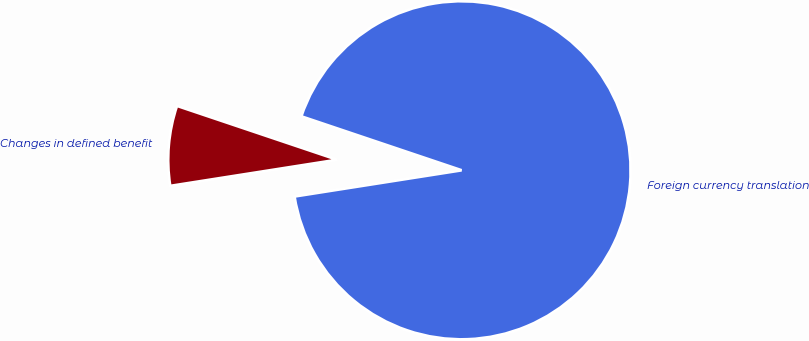Convert chart to OTSL. <chart><loc_0><loc_0><loc_500><loc_500><pie_chart><fcel>Foreign currency translation<fcel>Changes in defined benefit<nl><fcel>92.36%<fcel>7.64%<nl></chart> 